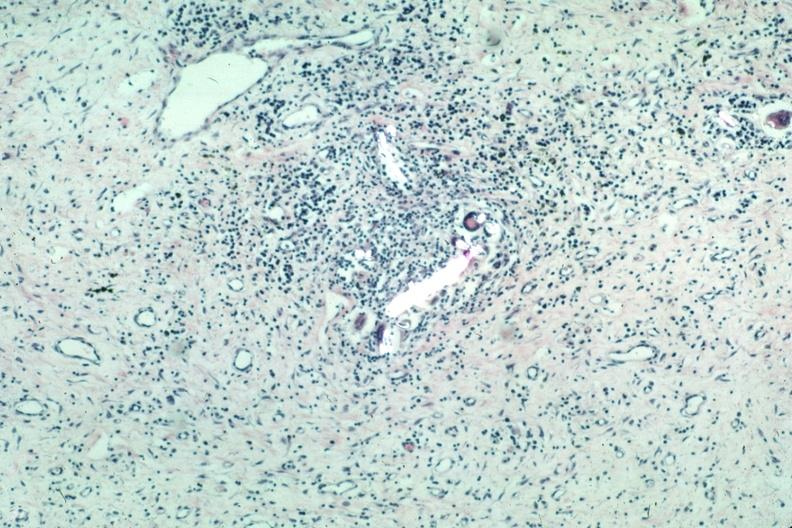where is this?
Answer the question using a single word or phrase. Skin 